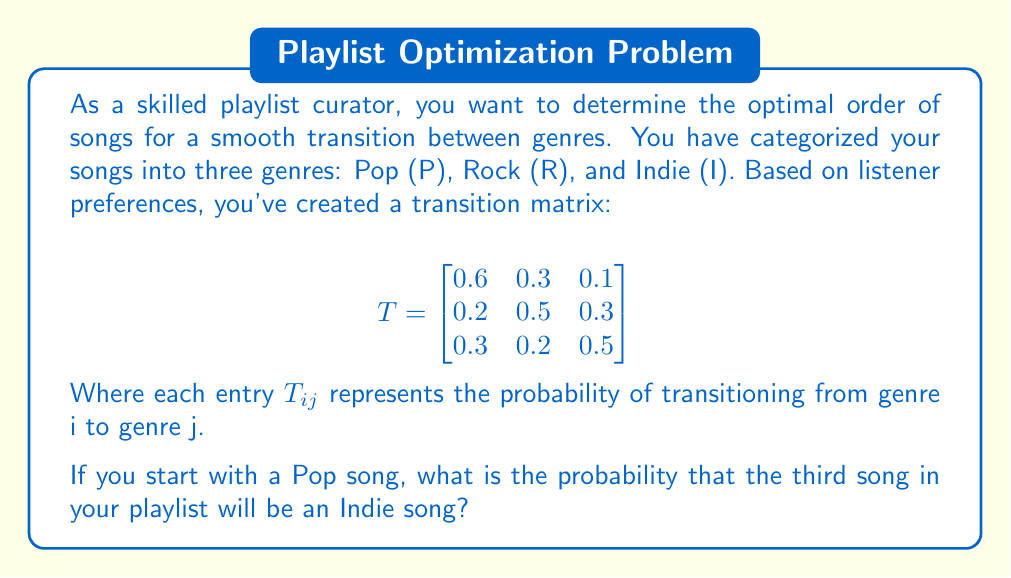Provide a solution to this math problem. To solve this problem, we need to use matrix multiplication to determine the probability distribution after two transitions.

Step 1: Identify the initial state vector.
Since we start with a Pop song, our initial state vector is:
$v_0 = \begin{bmatrix} 1 \\ 0 \\ 0 \end{bmatrix}$

Step 2: Calculate the state after one transition.
$v_1 = T \cdot v_0 = \begin{bmatrix}
0.6 & 0.3 & 0.1 \\
0.2 & 0.5 & 0.3 \\
0.3 & 0.2 & 0.5
\end{bmatrix} \cdot \begin{bmatrix} 1 \\ 0 \\ 0 \end{bmatrix} = \begin{bmatrix} 0.6 \\ 0.2 \\ 0.3 \end{bmatrix}$

Step 3: Calculate the state after two transitions.
$v_2 = T \cdot v_1 = \begin{bmatrix}
0.6 & 0.3 & 0.1 \\
0.2 & 0.5 & 0.3 \\
0.3 & 0.2 & 0.5
\end{bmatrix} \cdot \begin{bmatrix} 0.6 \\ 0.2 \\ 0.3 \end{bmatrix}$

$v_2 = \begin{bmatrix} 
(0.6 \cdot 0.6) + (0.3 \cdot 0.2) + (0.1 \cdot 0.3) \\
(0.2 \cdot 0.6) + (0.5 \cdot 0.2) + (0.3 \cdot 0.3) \\
(0.3 \cdot 0.6) + (0.2 \cdot 0.2) + (0.5 \cdot 0.3)
\end{bmatrix} = \begin{bmatrix} 0.45 \\ 0.31 \\ 0.24 \end{bmatrix}$

Step 4: Interpret the result.
The third element of $v_2$ (0.24) represents the probability that the third song will be an Indie song.
Answer: 0.24 